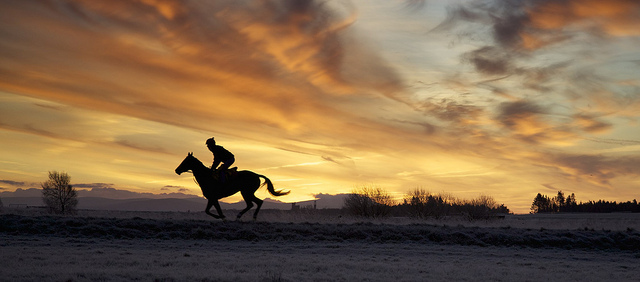What time of day does this photo seem to be taken? The photo appears to be taken during twilight, given the orange and golden hues in the sky, which are typical of the time shortly after sunset or just before sunrise. 